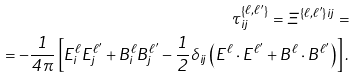<formula> <loc_0><loc_0><loc_500><loc_500>\tau _ { i j } ^ { \left \{ \ell , \ell ^ { \prime } \right \} } = \Xi ^ { \left \{ \ell , \ell ^ { \prime } \right \} i j } = \\ = - \frac { 1 } { 4 \pi } \left [ E _ { i } ^ { \ell } E _ { j } ^ { \ell ^ { \prime } } + B _ { i } ^ { \ell } B _ { j } ^ { \ell ^ { \prime } } - \frac { 1 } { 2 } \delta _ { i j } \left ( E ^ { \ell } \cdot E ^ { \ell ^ { \prime } } + B ^ { \ell } \cdot B ^ { \ell ^ { \prime } } \right ) \right ] .</formula> 